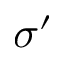Convert formula to latex. <formula><loc_0><loc_0><loc_500><loc_500>\sigma ^ { \prime }</formula> 